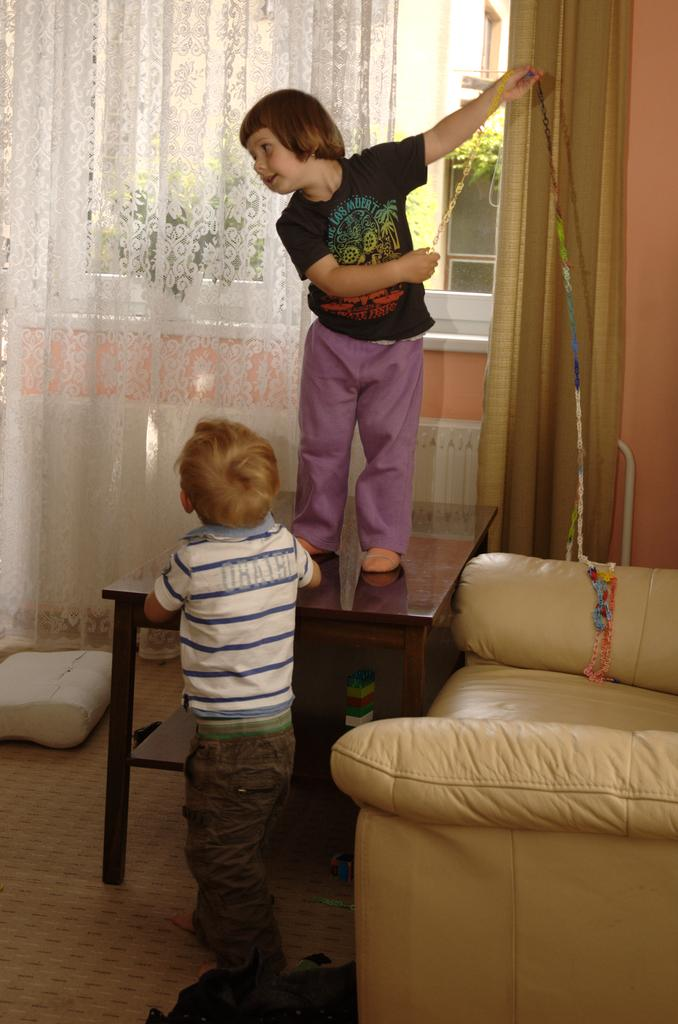What can be seen in the image that provides a view of the outside? There is a window in the image. What is used to cover or control the amount of light coming through the window? There is a curtain associated with the window. What type of furniture is present in the image? There is a sofa in the image. How many people are visible in the image? There are two people in the image. What type of drum can be heard playing in the background of the image? There is no drum or sound present in the image; it is a still image. 